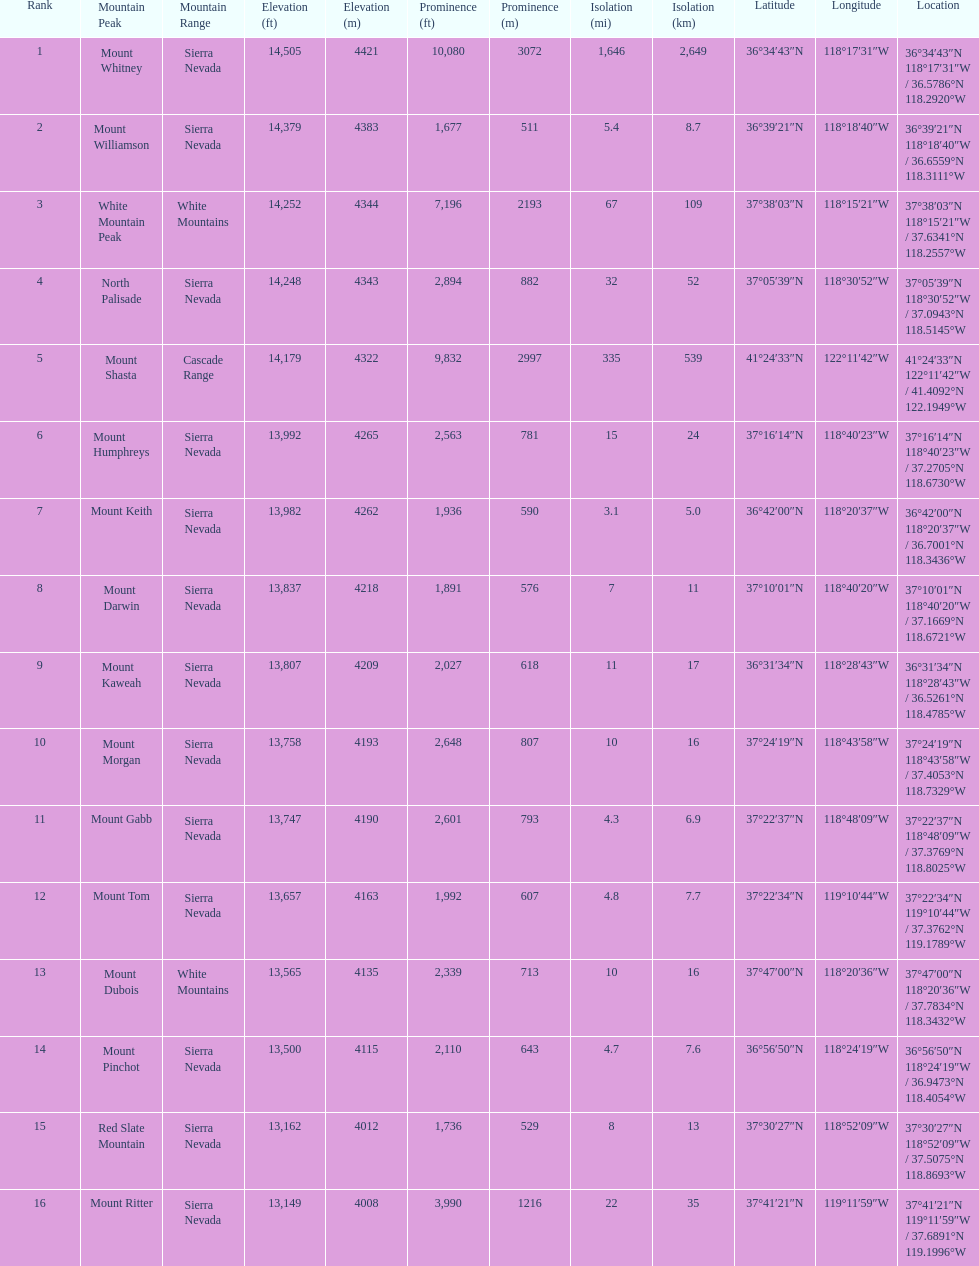How much taller is the mountain peak of mount williamson than that of mount keith? 397 ft. 